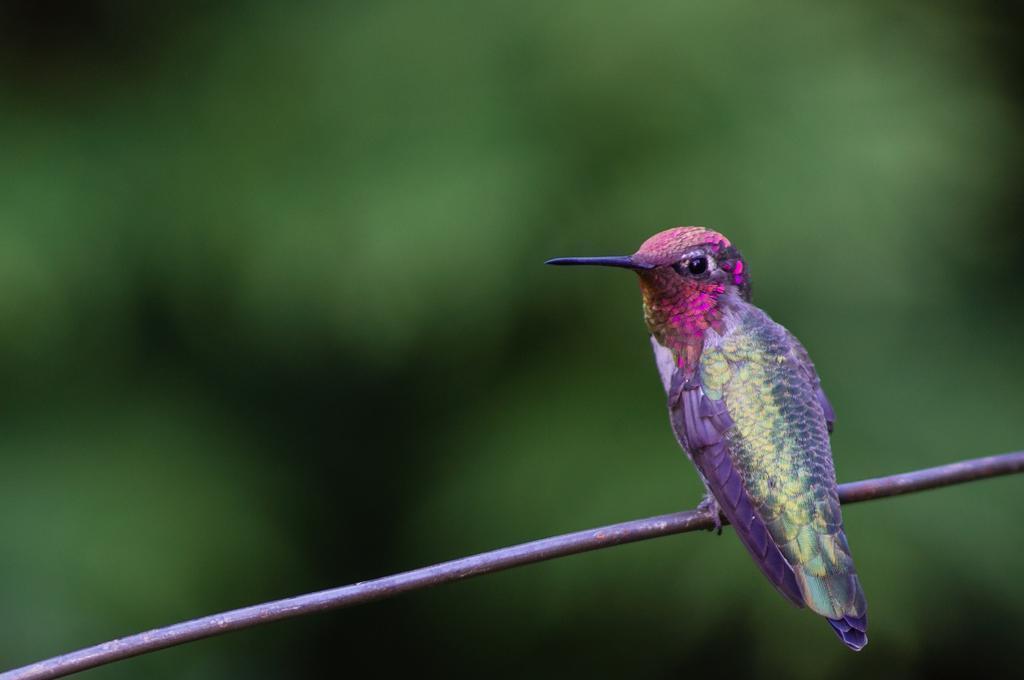In one or two sentences, can you explain what this image depicts? Background portion of the picture is completely blur. In this picture we can see a bird on an object. It looks like a wire. 